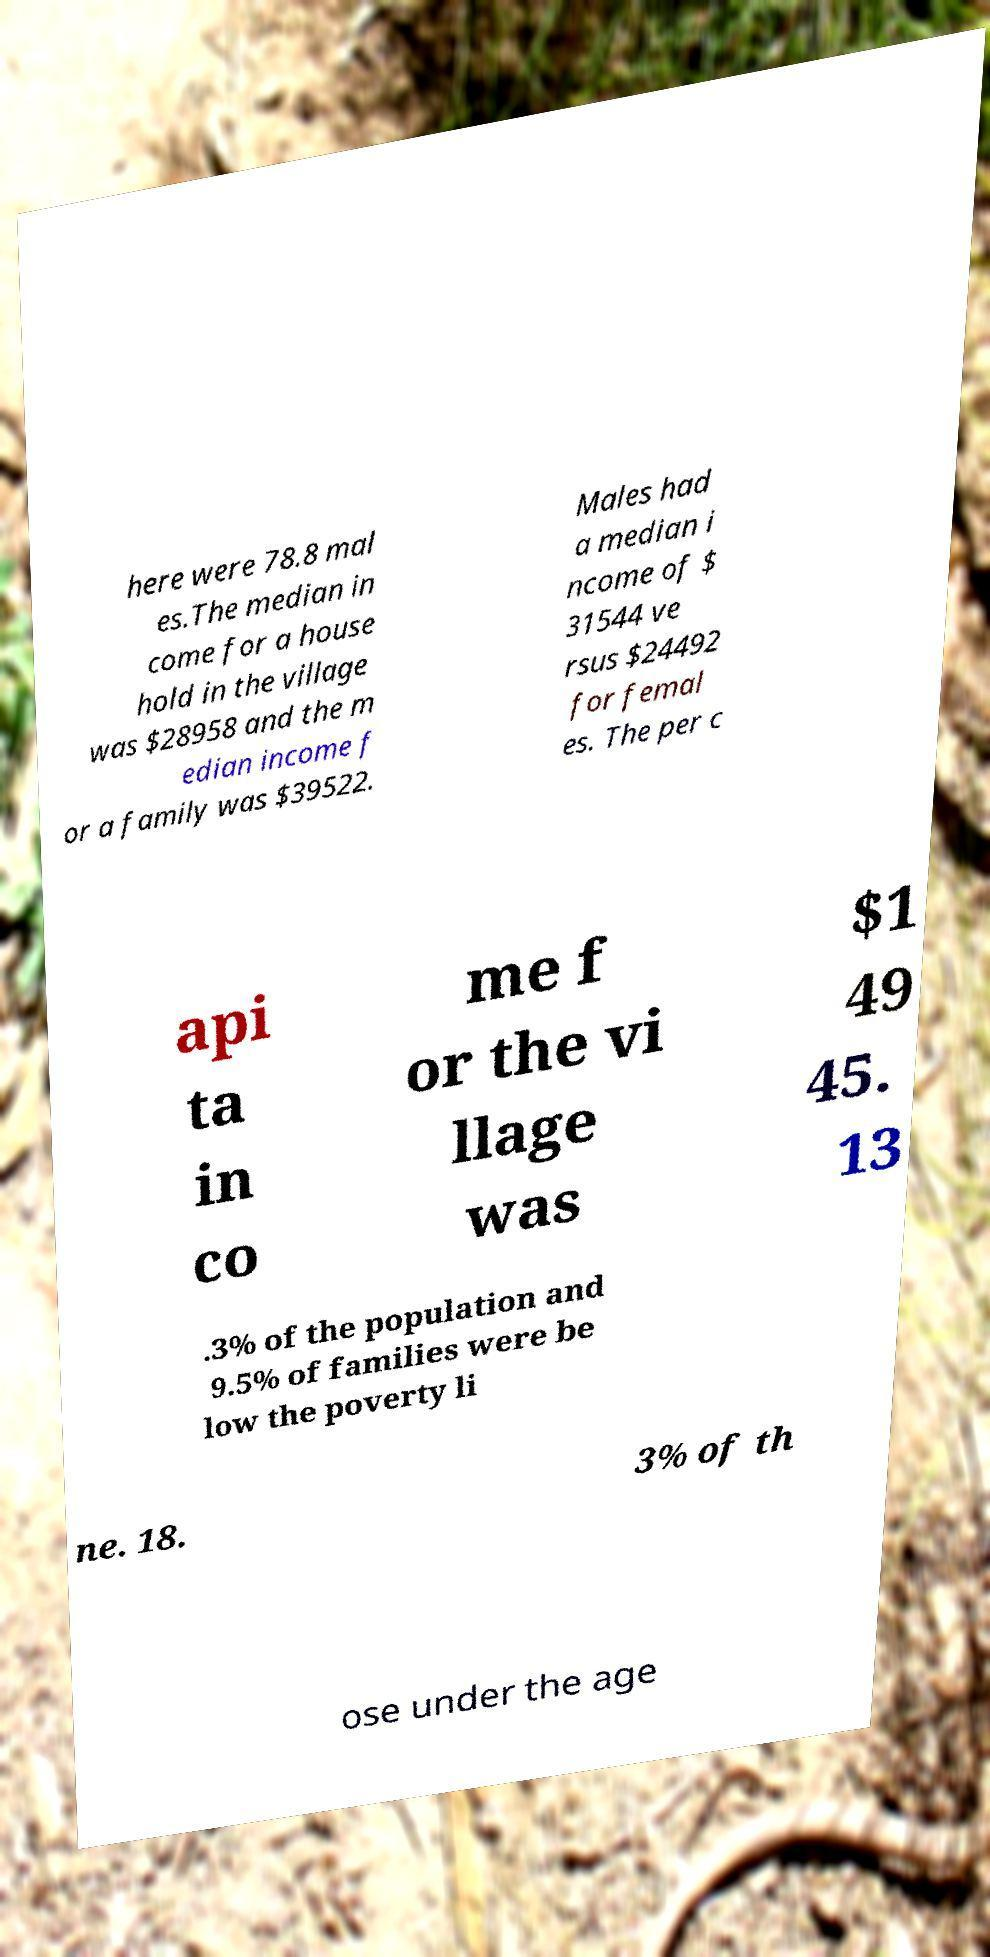Could you extract and type out the text from this image? here were 78.8 mal es.The median in come for a house hold in the village was $28958 and the m edian income f or a family was $39522. Males had a median i ncome of $ 31544 ve rsus $24492 for femal es. The per c api ta in co me f or the vi llage was $1 49 45. 13 .3% of the population and 9.5% of families were be low the poverty li ne. 18. 3% of th ose under the age 